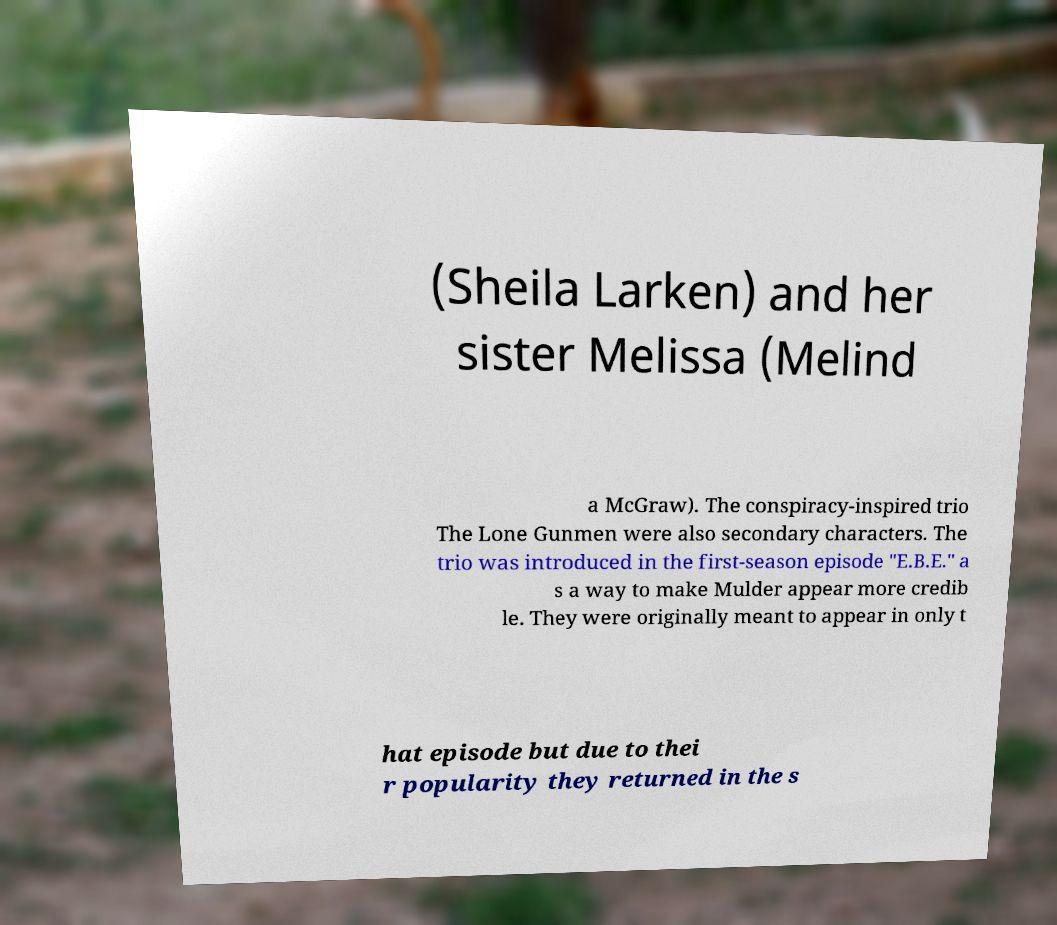What messages or text are displayed in this image? I need them in a readable, typed format. (Sheila Larken) and her sister Melissa (Melind a McGraw). The conspiracy-inspired trio The Lone Gunmen were also secondary characters. The trio was introduced in the first-season episode "E.B.E." a s a way to make Mulder appear more credib le. They were originally meant to appear in only t hat episode but due to thei r popularity they returned in the s 